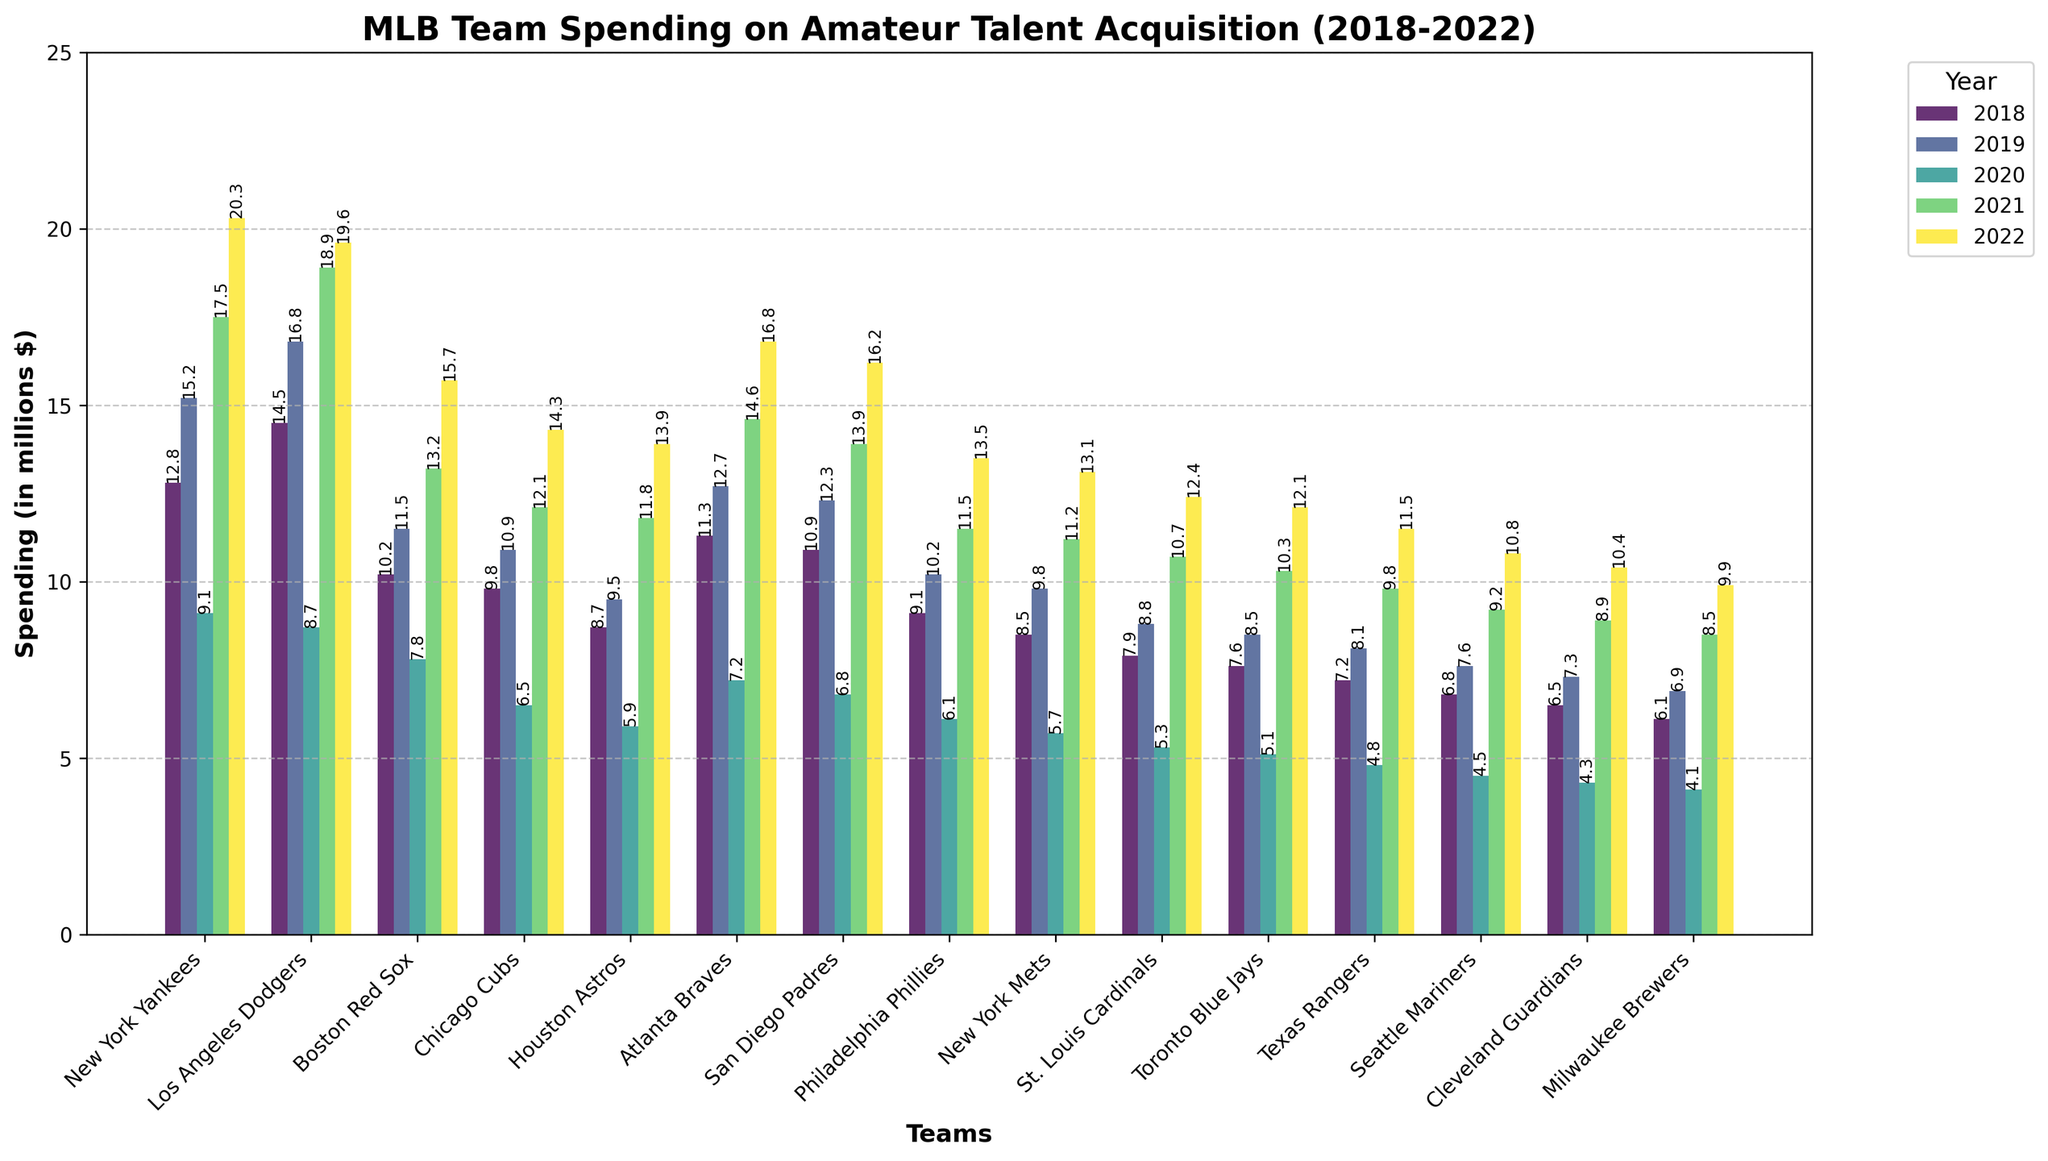What is the total spending of New York Yankees over the 5 years? To find the total spending, add the values from 2018 to 2022: 12.8 + 15.2 + 9.1 + 17.5 + 20.3.
Answer: 74.9 Which team had the highest spending in 2021? To determine the team with the highest spending in 2021, compare the heights of the bars for that year. The New York Yankees have the tallest bar.
Answer: New York Yankees What is the difference in 2022 spending between the Los Angeles Dodgers and the Cleveland Guardians? Subtract the 2022 spending of the Cleveland Guardians from that of the Los Angeles Dodgers: 19.6 - 10.4.
Answer: 9.2 How has the spending trend for the Houston Astros changed from 2018 to 2022? Observe the progression of the bar heights for the Houston Astros from 2018 to 2022, which show an increasing trend: 8.7, 9.5, 5.9, 11.8, 13.9.
Answer: Increasing Which team had the smallest spending in 2020, and what was the value? By comparing the heights of the bars in 2020, the Milwaukee Brewers have the smallest bar. The value is 4.1.
Answer: Milwaukee Brewers, 4.1 Is the spending of the Philadelphia Phillies in 2022 greater than or equal to the spending of the New York Mets in 2022? By comparing the heights of the bars for 2022, the Philadelphia Phillies spent 13.5 and the New York Mets spent 13.1. 13.5 is greater than 13.1.
Answer: Yes What is the average spending of the Texas Rangers over the 5 years? To find the average, sum the values from 2018 to 2022 and divide by 5: (7.2 + 8.1 + 4.8 + 9.8 + 11.5) / 5.
Answer: 8.28 Which team showed the largest increase in spending between 2020 and 2021? Compare the increase in spending for all teams between 2020 and 2021, where the New York Yankees increased from 9.1 to 17.5, which is the highest increase.
Answer: New York Yankees What is the combined spending of the Boston Red Sox and the Atlanta Braves in 2021? Add the spending values of both teams in 2021: 13.2 (Boston Red Sox) + 14.6 (Atlanta Braves).
Answer: 27.8 